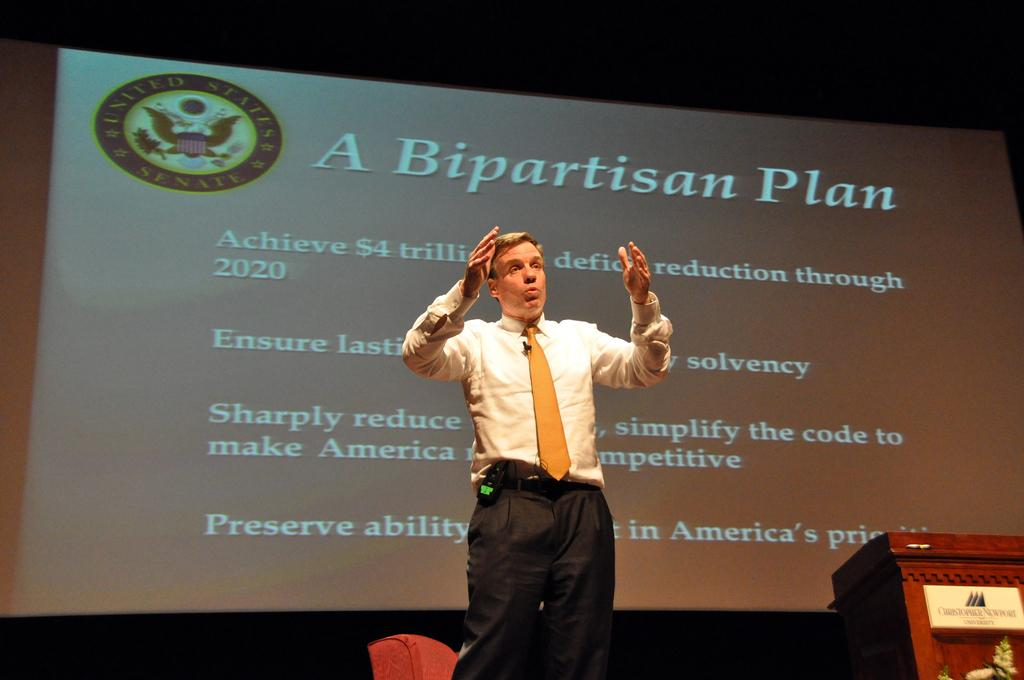What is the main object in the image? There is a screen in the image. Who or what is present in the image? There is a man in the image. What is the man wearing? The man is wearing a white shirt. What can be seen on the screen? There is text or content on the screen. What type of tin can be seen in the image? There is no tin present in the image. How does the ray affect the man in the image? There is no ray present in the image, so its effect cannot be determined. 